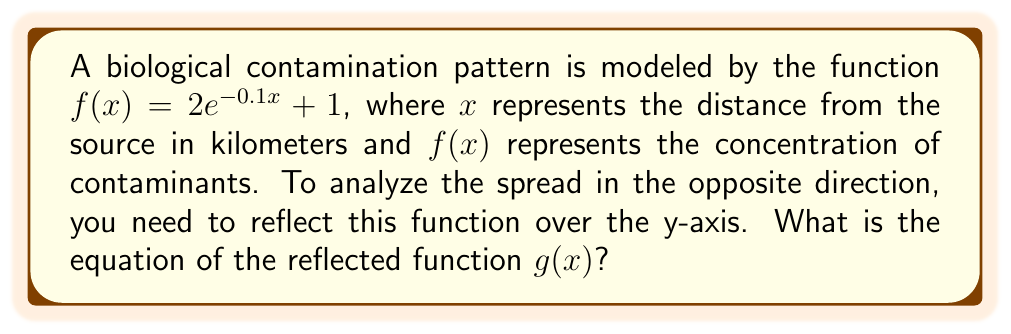Can you answer this question? To reflect a function over the y-axis, we replace every $x$ in the original function with $-x$. This is because the y-axis reflection changes the sign of the x-coordinate for every point.

Step 1: Start with the original function
$$f(x) = 2e^{-0.1x} + 1$$

Step 2: Replace every $x$ with $-x$
$$g(x) = 2e^{-0.1(-x)} + 1$$

Step 3: Simplify the exponent
$$g(x) = 2e^{0.1x} + 1$$

The resulting function $g(x) = 2e^{0.1x} + 1$ represents the biological contamination pattern reflected over the y-axis, showing the spread in the opposite direction from the original source.
Answer: $g(x) = 2e^{0.1x} + 1$ 